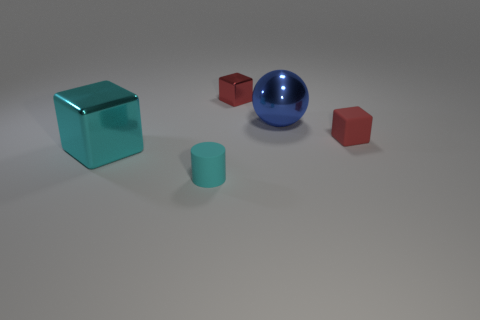What number of cyan matte cylinders are there?
Keep it short and to the point. 1. How many small red things are right of the small red metallic object?
Give a very brief answer. 1. Is the material of the big ball the same as the large cyan thing?
Provide a short and direct response. Yes. What number of objects are both to the right of the large cyan block and to the left of the big blue metal object?
Keep it short and to the point. 2. What number of other things are there of the same color as the matte block?
Offer a terse response. 1. How many purple objects are big things or small rubber blocks?
Provide a succinct answer. 0. What is the size of the red matte thing?
Your answer should be compact. Small. How many rubber things are either large blue objects or tiny cylinders?
Your response must be concise. 1. Are there fewer big cyan metal blocks than green metal things?
Your answer should be compact. No. What number of other objects are the same material as the large cube?
Ensure brevity in your answer.  2. 